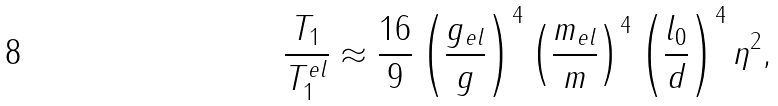<formula> <loc_0><loc_0><loc_500><loc_500>\frac { T _ { 1 } } { T _ { 1 } ^ { e l } } \approx \frac { 1 6 } { 9 } \left ( \frac { g _ { e l } } { g } \right ) ^ { 4 } \left ( \frac { m _ { e l } } { m } \right ) ^ { 4 } \left ( \frac { l _ { 0 } } { d } \right ) ^ { 4 } \eta ^ { 2 } ,</formula> 